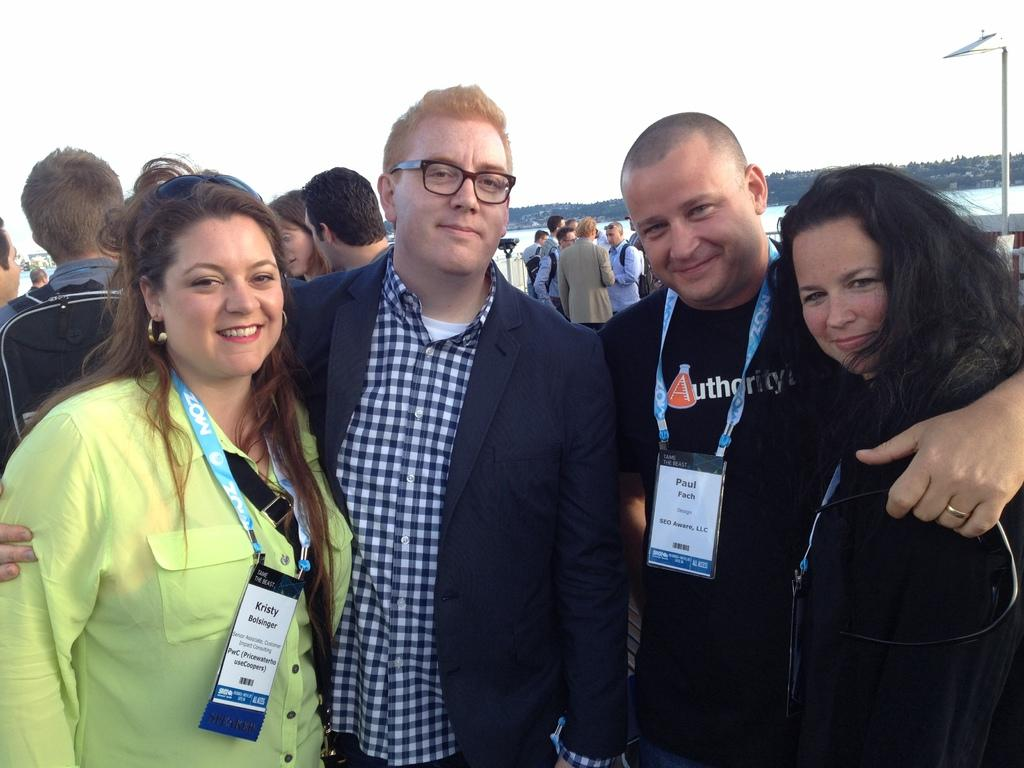What are the people in the front of the image doing? The persons standing in the front of the image are smiling. Can you describe the people in the background of the image? There are persons standing in the background of the image. What can be seen in the background of the image besides the people? There is a pole, water, and trees visible in the background of the image. What type of screw can be seen holding the bridge together in the image? There is no bridge or screw present in the image. Who are the friends standing together in the image? The provided facts do not mention any specific friends or relationships between the people in the image. 